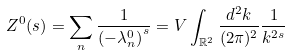<formula> <loc_0><loc_0><loc_500><loc_500>Z ^ { 0 } ( s ) = \sum _ { n } \frac { 1 } { \left ( - \lambda _ { n } ^ { 0 } \right ) ^ { s } } = V \int _ { \mathbb { R } ^ { 2 } } \frac { d ^ { 2 } k } { ( 2 \pi ) ^ { 2 } } \frac { 1 } { k ^ { 2 s } }</formula> 